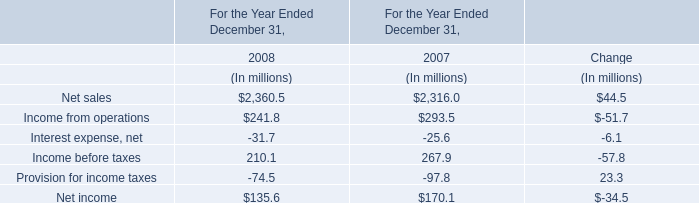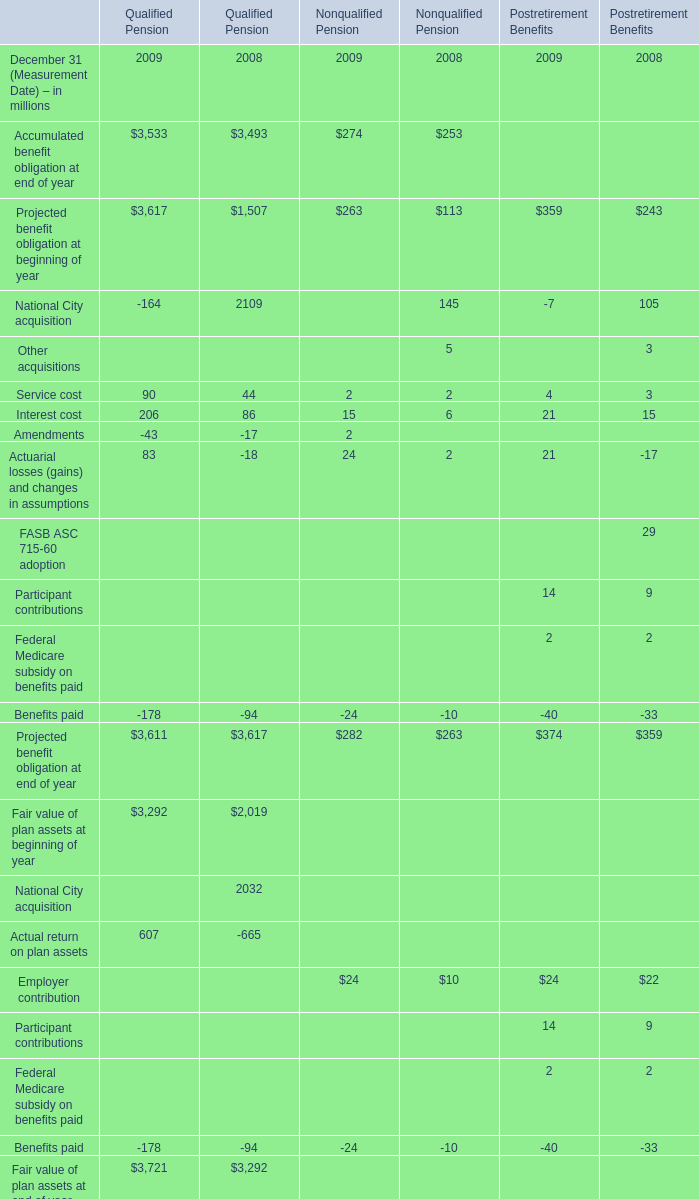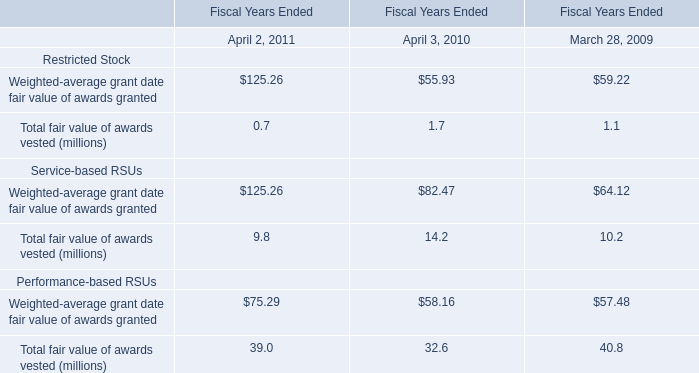Which element has the second largest number in 2009 for Qualified Pension 
Answer: Projected benefit obligation at beginning of year. 